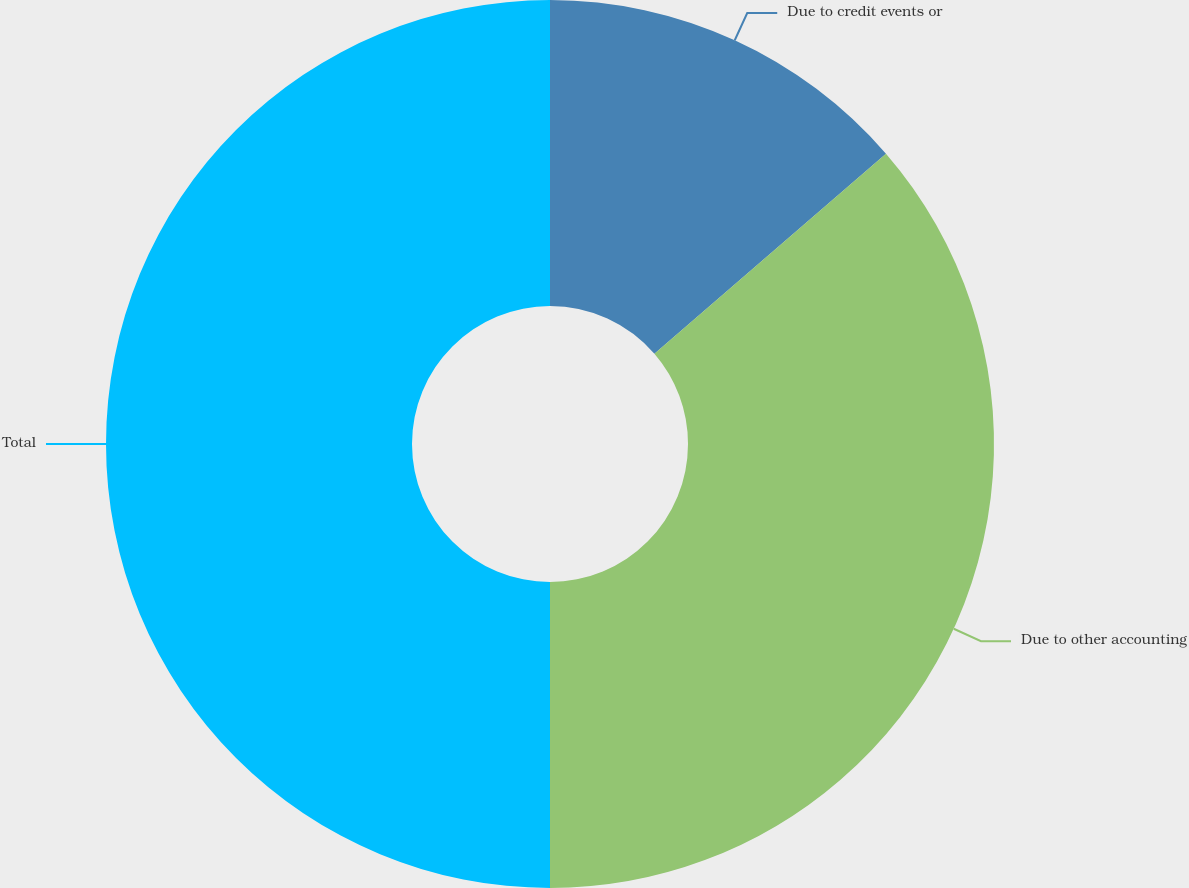Convert chart. <chart><loc_0><loc_0><loc_500><loc_500><pie_chart><fcel>Due to credit events or<fcel>Due to other accounting<fcel>Total<nl><fcel>13.66%<fcel>36.34%<fcel>50.0%<nl></chart> 